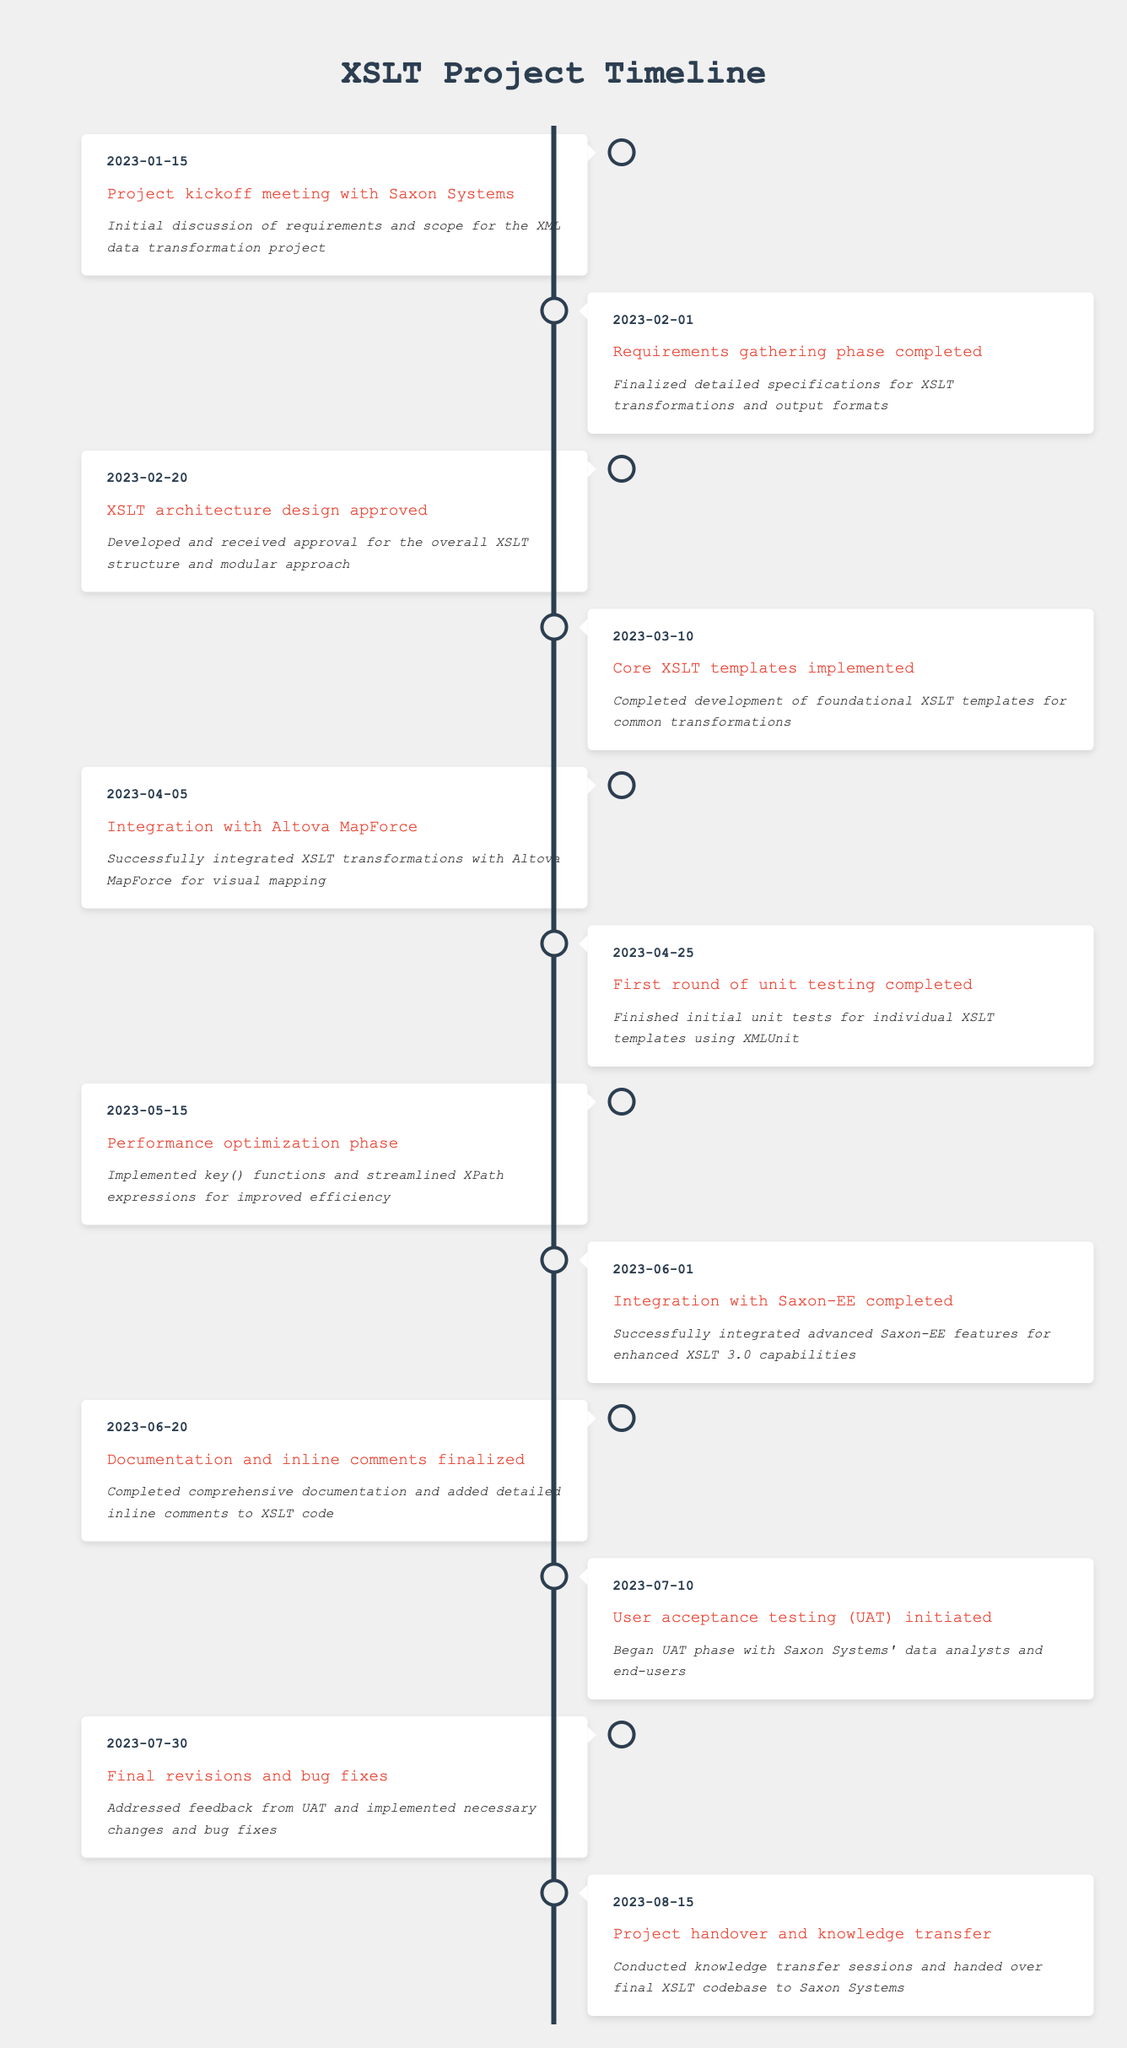What was the date of the project kickoff meeting? The date of the project kickoff meeting is directly provided in the table under the first row's date column. It is "2023-01-15."
Answer: 2023-01-15 How many weeks were there between the completion of the requirements gathering phase and the integration with Saxon-EE? The requirements gathering phase was completed on "2023-02-01," and the integration with Saxon-EE was completed on "2023-06-01." The duration from February 1 to June 1 is 120 days, or approximately 17 weeks.
Answer: 17 weeks Was the integration with Altova MapForce completed before or after the first round of unit testing? The integration with Altova MapForce was logged on "2023-04-05," and the first round of unit testing was logged on "2023-04-25." Since April 5 is before April 25, the integration was completed prior to the testing phase.
Answer: Before How many milestones were completed by mid-June 2023? The milestones completed by mid-June include the project kickoff, requirements gathering, architecture design approval, core templates implementation, Altova MapForce integration, unit testing, and performance optimization. Thus, a total of 6 milestones were completed by June 15, 2023.
Answer: 6 milestones Which milestone occurred last before the project handover? The last milestone before the project handover on "2023-08-15" was "Final revisions and bug fixes," which occurred on "2023-07-30." This is the immediate previous milestone listed in the timeline.
Answer: Final revisions and bug fixes What is the average time between each of the first three milestones? The first three milestones occurred on "2023-01-15," "2023-02-01," and "2023-02-20." The time spans between them are: From January 15 to February 1 is 16 days, and from February 1 to February 20 is 19 days. The total time between these milestones is 35 days over 2 intervals, giving an average of 17.5 days.
Answer: 17.5 days 